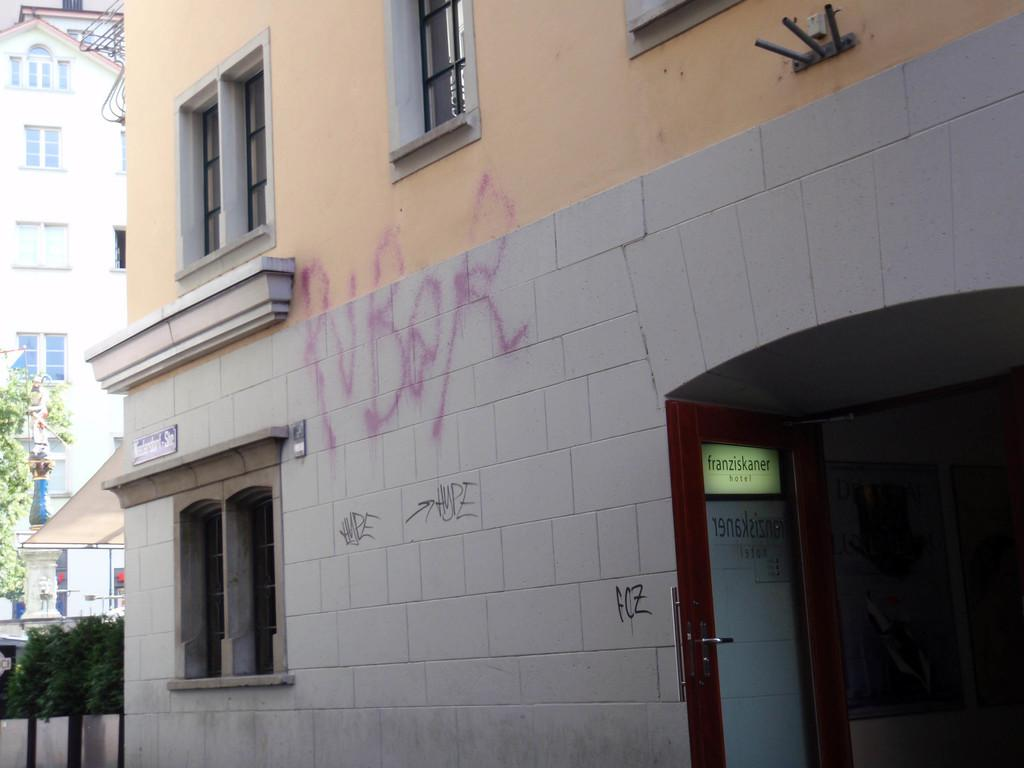What type of structures are visible in the image? There are buildings in the image. Where is the door located in the image? The door is on the right side of the image. What type of vegetation is on the left side of the image? There are trees on the left side of the image. What type of lipstick is being sold in the store in the image? There is no store or lipstick present in the image; it features buildings, a door, and trees. How many horses are pulling the carriage in the image? There is no carriage or horses present in the image. 